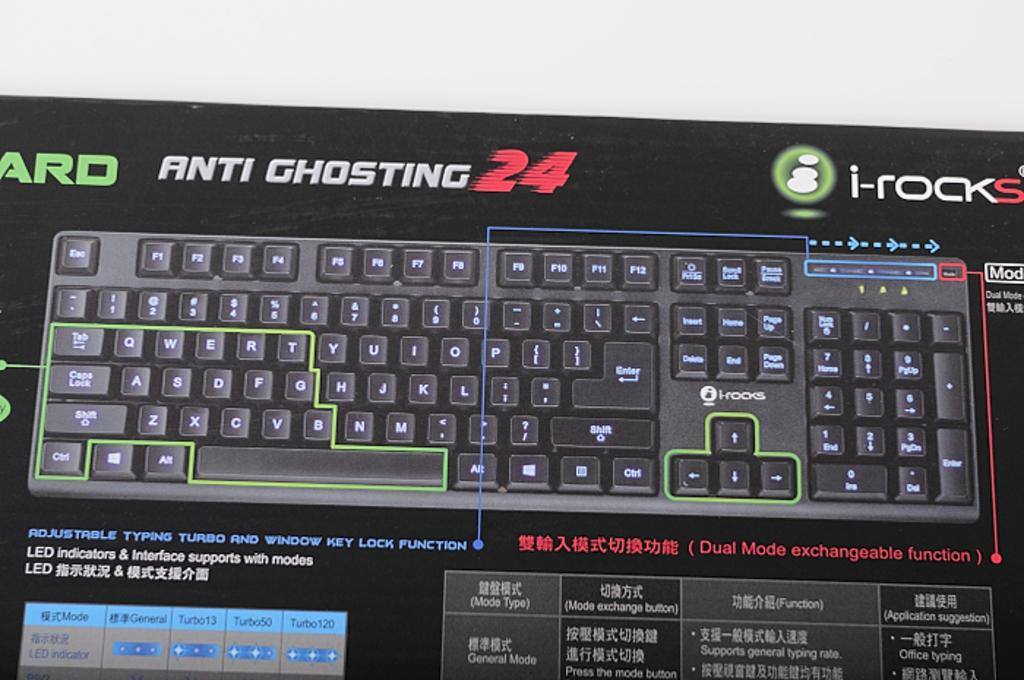Provide a one-sentence caption for the provided image. The Anit Ghosting 24 keyboard by i-rocks includes features like adjustable typing turbo and window key lock. 